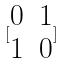<formula> <loc_0><loc_0><loc_500><loc_500>[ \begin{matrix} 0 & 1 \\ 1 & 0 \end{matrix} ]</formula> 